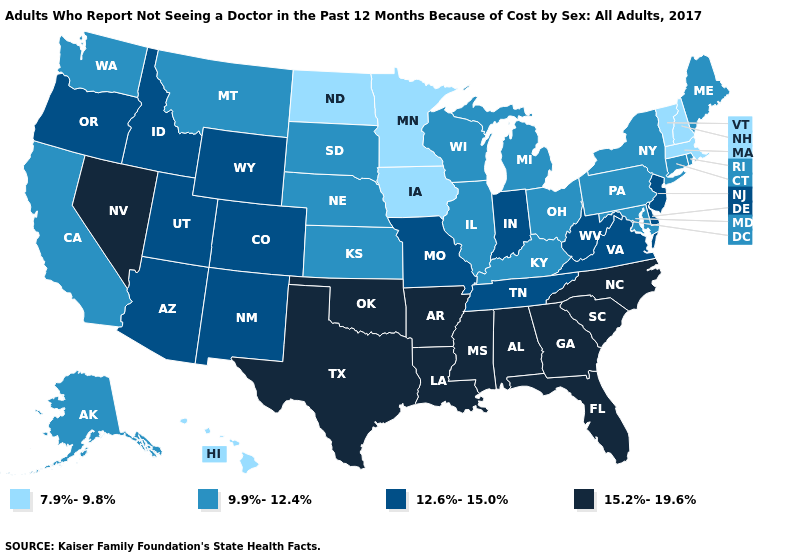What is the value of Iowa?
Short answer required. 7.9%-9.8%. Which states hav the highest value in the South?
Give a very brief answer. Alabama, Arkansas, Florida, Georgia, Louisiana, Mississippi, North Carolina, Oklahoma, South Carolina, Texas. What is the highest value in the MidWest ?
Write a very short answer. 12.6%-15.0%. How many symbols are there in the legend?
Quick response, please. 4. Name the states that have a value in the range 7.9%-9.8%?
Keep it brief. Hawaii, Iowa, Massachusetts, Minnesota, New Hampshire, North Dakota, Vermont. Name the states that have a value in the range 9.9%-12.4%?
Keep it brief. Alaska, California, Connecticut, Illinois, Kansas, Kentucky, Maine, Maryland, Michigan, Montana, Nebraska, New York, Ohio, Pennsylvania, Rhode Island, South Dakota, Washington, Wisconsin. What is the lowest value in the USA?
Write a very short answer. 7.9%-9.8%. What is the value of Wyoming?
Be succinct. 12.6%-15.0%. Name the states that have a value in the range 9.9%-12.4%?
Quick response, please. Alaska, California, Connecticut, Illinois, Kansas, Kentucky, Maine, Maryland, Michigan, Montana, Nebraska, New York, Ohio, Pennsylvania, Rhode Island, South Dakota, Washington, Wisconsin. What is the value of Alabama?
Answer briefly. 15.2%-19.6%. Which states have the lowest value in the USA?
Concise answer only. Hawaii, Iowa, Massachusetts, Minnesota, New Hampshire, North Dakota, Vermont. Among the states that border Delaware , does Pennsylvania have the lowest value?
Write a very short answer. Yes. Does Kentucky have the lowest value in the South?
Keep it brief. Yes. How many symbols are there in the legend?
Answer briefly. 4. How many symbols are there in the legend?
Keep it brief. 4. 